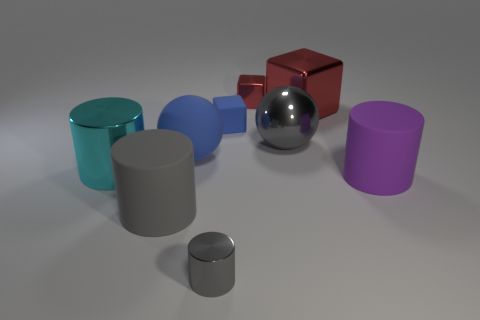Is there anything else that has the same color as the big metal cylinder?
Make the answer very short. No. There is a gray sphere that is made of the same material as the large block; what is its size?
Offer a terse response. Large. There is a tiny blue matte thing; does it have the same shape as the big gray object that is on the right side of the small rubber object?
Offer a very short reply. No. What size is the gray metallic cylinder?
Offer a very short reply. Small. Is the number of tiny gray cylinders to the left of the cyan shiny cylinder less than the number of tiny brown shiny things?
Offer a terse response. No. How many gray cylinders have the same size as the gray matte thing?
Offer a terse response. 0. There is a rubber object that is the same color as the small matte cube; what is its shape?
Keep it short and to the point. Sphere. Do the metallic thing that is behind the large red object and the large metal object to the right of the big gray metal object have the same color?
Offer a terse response. Yes. There is a blue block; what number of gray cylinders are on the left side of it?
Make the answer very short. 2. There is a matte cylinder that is the same color as the shiny sphere; what size is it?
Your answer should be compact. Large. 